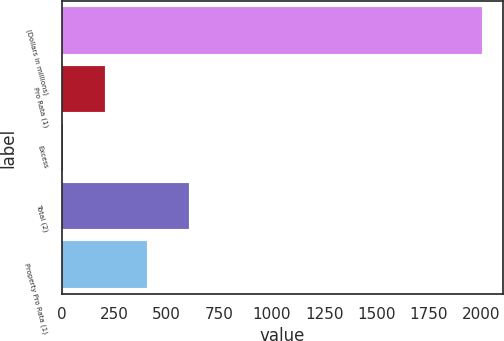Convert chart. <chart><loc_0><loc_0><loc_500><loc_500><bar_chart><fcel>(Dollars in millions)<fcel>Pro Rata (1)<fcel>Excess<fcel>Total (2)<fcel>Property Pro Rata (1)<nl><fcel>2003<fcel>205.07<fcel>5.3<fcel>604.61<fcel>404.84<nl></chart> 